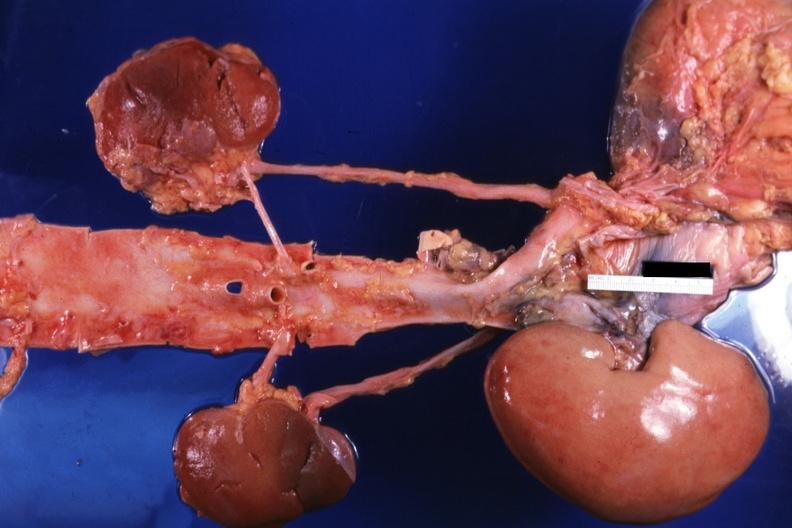where is this?
Answer the question using a single word or phrase. Urinary 